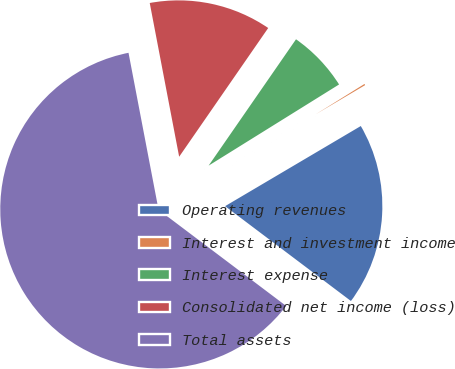<chart> <loc_0><loc_0><loc_500><loc_500><pie_chart><fcel>Operating revenues<fcel>Interest and investment income<fcel>Interest expense<fcel>Consolidated net income (loss)<fcel>Total assets<nl><fcel>18.77%<fcel>0.37%<fcel>6.51%<fcel>12.64%<fcel>61.71%<nl></chart> 